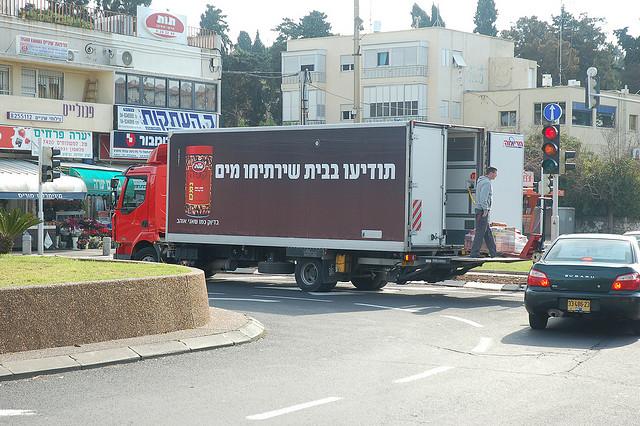What is the sign on the truck?
Concise answer only. Peanuts. Is the truck a garbage truck?
Quick response, please. No. What is the language on the truck?
Concise answer only. Hebrew. What color is the truck?
Write a very short answer. Red. Where would a taxi park to wait for a customer?
Concise answer only. Curb. How many trucks are parked on the road?
Be succinct. 1. How many vehicles are in the scene?
Concise answer only. 2. What soda is advertising?
Write a very short answer. Coke. 